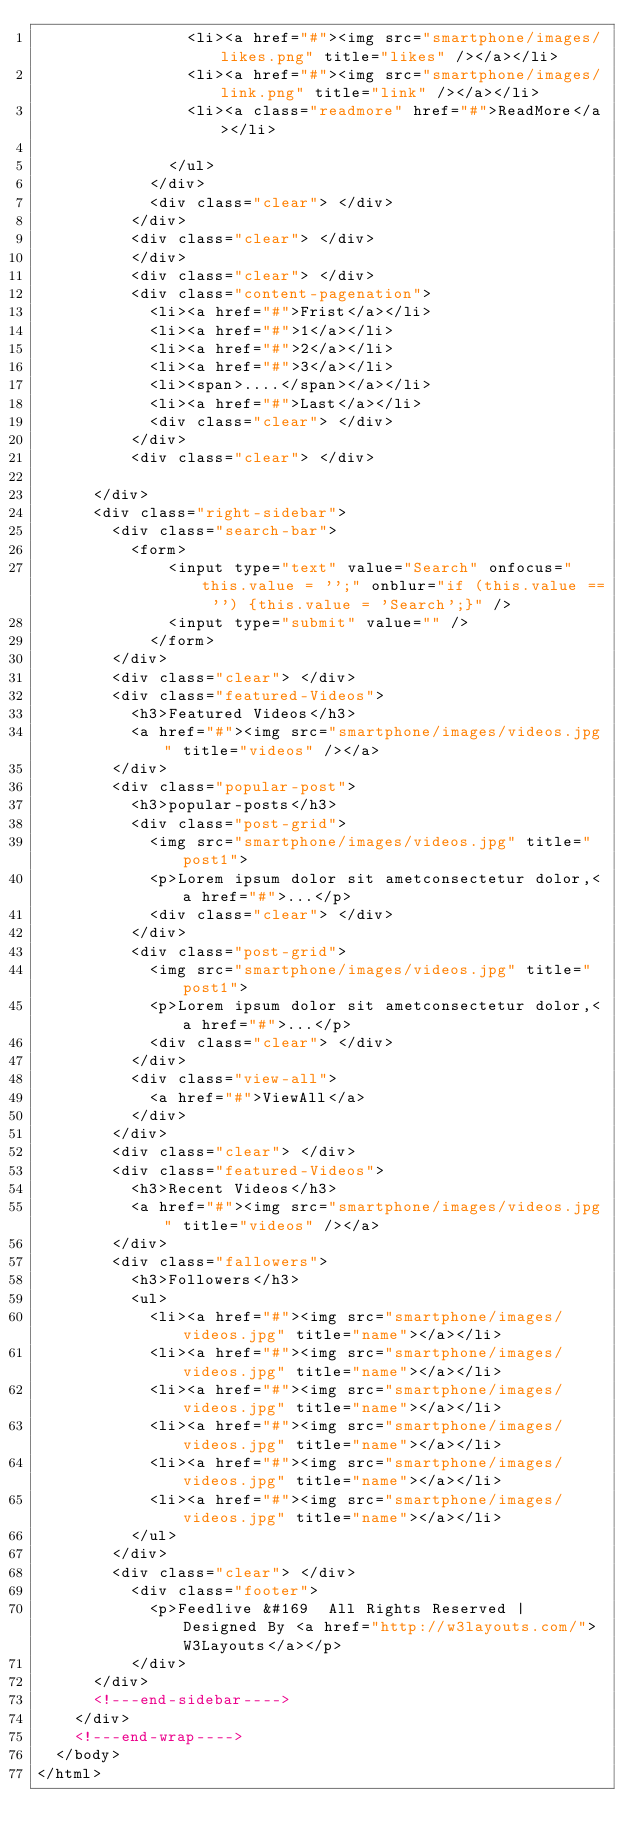Convert code to text. <code><loc_0><loc_0><loc_500><loc_500><_HTML_>								<li><a href="#"><img src="smartphone/images/likes.png" title="likes" /></a></li>
								<li><a href="#"><img src="smartphone/images/link.png" title="link" /></a></li>
								<li><a class="readmore" href="#">ReadMore</a></li>
								
							</ul>
						</div>
						<div class="clear"> </div>
					</div>
					<div class="clear"> </div>
					</div>
					<div class="clear"> </div>
					<div class="content-pagenation">
						<li><a href="#">Frist</a></li>
						<li><a href="#">1</a></li>
						<li><a href="#">2</a></li>
						<li><a href="#">3</a></li>
						<li><span>....</span></a></li>
						<li><a href="#">Last</a></li>
						<div class="clear"> </div>
					</div>
					<div class="clear"> </div>
					
			</div>
			<div class="right-sidebar">
				<div class="search-bar">
					<form>
			    		<input type="text" value="Search" onfocus="this.value = '';" onblur="if (this.value == '') {this.value = 'Search';}" />
			    		<input type="submit" value="" />
			    	</form>
				</div>
				<div class="clear"> </div>
				<div class="featured-Videos">
					<h3>Featured Videos</h3>
					<a href="#"><img src="smartphone/images/videos.jpg" title="videos" /></a>
				</div>
				<div class="popular-post">
					<h3>popular-posts</h3>
					<div class="post-grid">
						<img src="smartphone/images/videos.jpg" title="post1">
						<p>Lorem ipsum dolor sit ametconsectetur dolor,<a href="#">...</p>
						<div class="clear"> </div>
					</div>
					<div class="post-grid">
						<img src="smartphone/images/videos.jpg" title="post1">
						<p>Lorem ipsum dolor sit ametconsectetur dolor,<a href="#">...</p>
						<div class="clear"> </div>
					</div>
					<div class="view-all">
						<a href="#">ViewAll</a>
					</div>
				</div>
				<div class="clear"> </div>
				<div class="featured-Videos">
					<h3>Recent Videos</h3>
					<a href="#"><img src="smartphone/images/videos.jpg" title="videos" /></a>
				</div>
				<div class="fallowers">
					<h3>Followers</h3>
					<ul>
						<li><a href="#"><img src="smartphone/images/videos.jpg" title="name"></a></li>
						<li><a href="#"><img src="smartphone/images/videos.jpg" title="name"></a></li>
						<li><a href="#"><img src="smartphone/images/videos.jpg" title="name"></a></li>
						<li><a href="#"><img src="smartphone/images/videos.jpg" title="name"></a></li>
						<li><a href="#"><img src="smartphone/images/videos.jpg" title="name"></a></li>
						<li><a href="#"><img src="smartphone/images/videos.jpg" title="name"></a></li>
					</ul>
				</div>
				<div class="clear"> </div>
					<div class="footer">
						<p>Feedlive &#169	 All Rights Reserved | Designed By <a href="http://w3layouts.com/">W3Layouts</a></p>
					</div>
			</div>
			<!---end-sidebar---->
		</div>
		<!---end-wrap---->
	</body>
</html>

</code> 